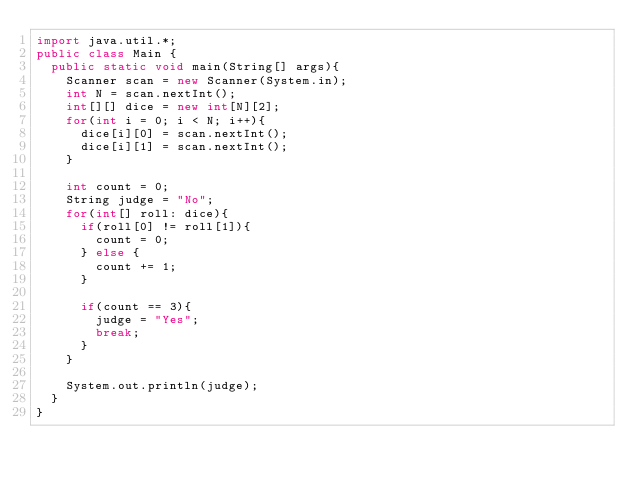Convert code to text. <code><loc_0><loc_0><loc_500><loc_500><_Java_>import java.util.*;
public class Main {
  public static void main(String[] args){
    Scanner scan = new Scanner(System.in);
    int N = scan.nextInt();
    int[][] dice = new int[N][2];
    for(int i = 0; i < N; i++){
      dice[i][0] = scan.nextInt();
      dice[i][1] = scan.nextInt();
    }
    
    int count = 0;
    String judge = "No";
    for(int[] roll: dice){
      if(roll[0] != roll[1]){
        count = 0;
      } else {
        count += 1;
      }
      
      if(count == 3){
        judge = "Yes";
        break;
      }
    }
    
    System.out.println(judge);	
  }
}</code> 